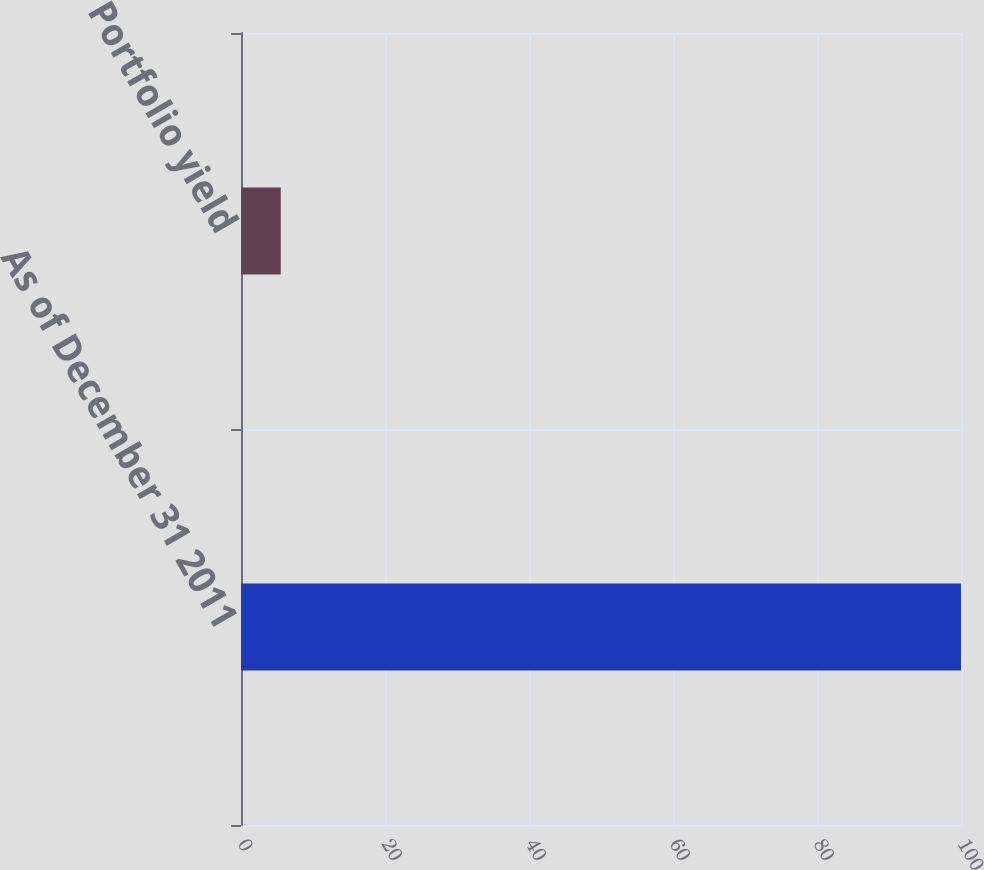Convert chart. <chart><loc_0><loc_0><loc_500><loc_500><bar_chart><fcel>As of December 31 2011<fcel>Portfolio yield<nl><fcel>100<fcel>5.52<nl></chart> 